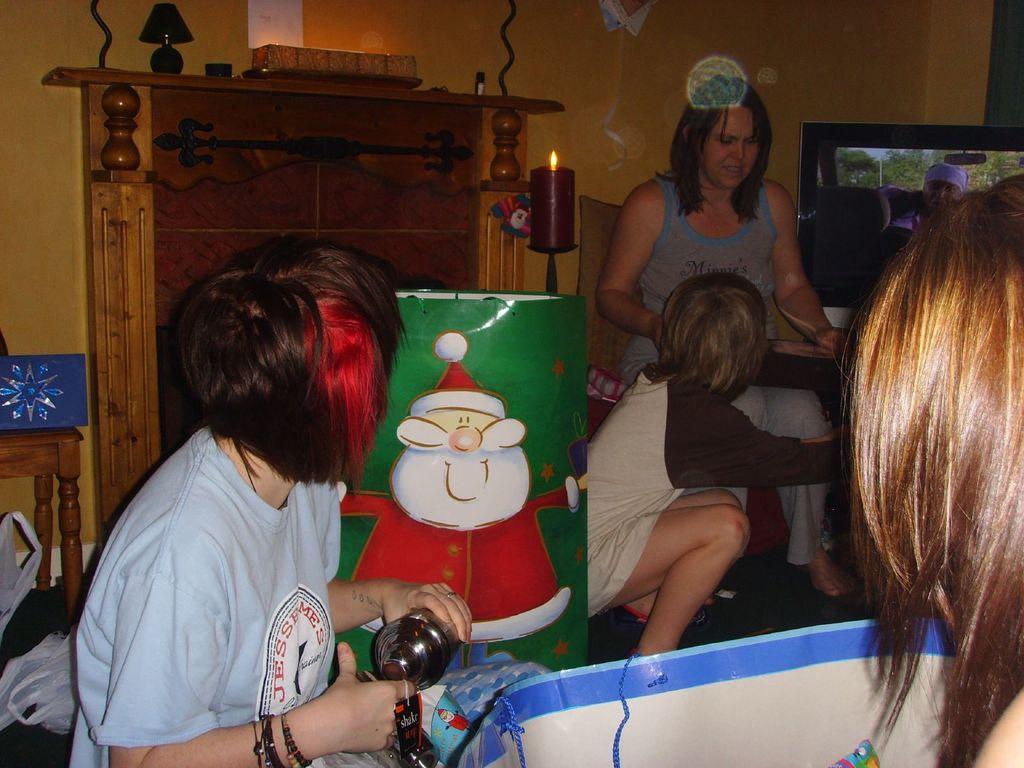In one or two sentences, can you explain what this image depicts? In this image we can see a group of people sitting. In that a woman is holding a metal container. We can also see a photo frame on the table, some covers on the floor, a lamp, a drum with some painting on it and a candle with flame. On the backside we can see a television and a wall. 